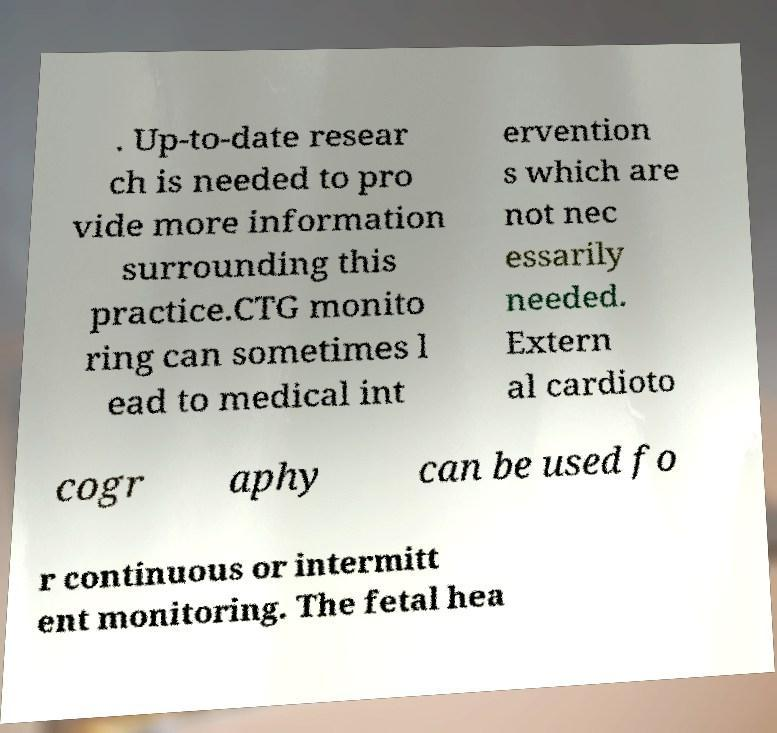Can you read and provide the text displayed in the image?This photo seems to have some interesting text. Can you extract and type it out for me? . Up-to-date resear ch is needed to pro vide more information surrounding this practice.CTG monito ring can sometimes l ead to medical int ervention s which are not nec essarily needed. Extern al cardioto cogr aphy can be used fo r continuous or intermitt ent monitoring. The fetal hea 